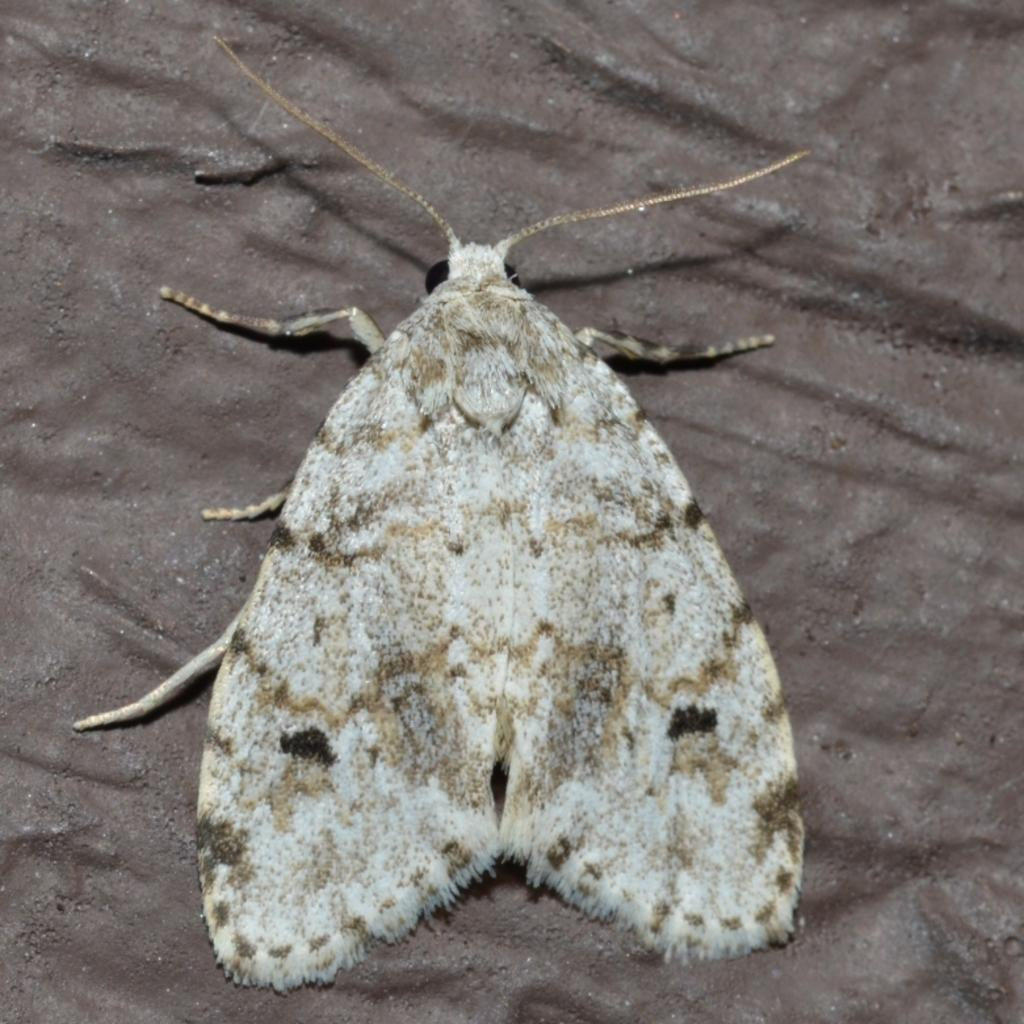What type of insect is present in the image? There is a moth in the image. Where is the moth located in the image? The moth is on a surface. How many lizards are crawling on the moth in the image? There are no lizards present in the image; it only features a moth on a surface. 